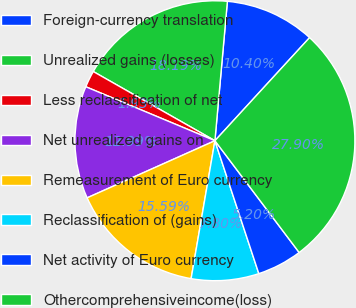Convert chart to OTSL. <chart><loc_0><loc_0><loc_500><loc_500><pie_chart><fcel>Foreign-currency translation<fcel>Unrealized gains (losses)<fcel>Less reclassification of net<fcel>Net unrealized gains on<fcel>Remeasurement of Euro currency<fcel>Reclassification of (gains)<fcel>Net activity of Euro currency<fcel>Othercomprehensiveincome(loss)<nl><fcel>10.4%<fcel>18.19%<fcel>1.93%<fcel>12.99%<fcel>15.59%<fcel>7.8%<fcel>5.2%<fcel>27.9%<nl></chart> 